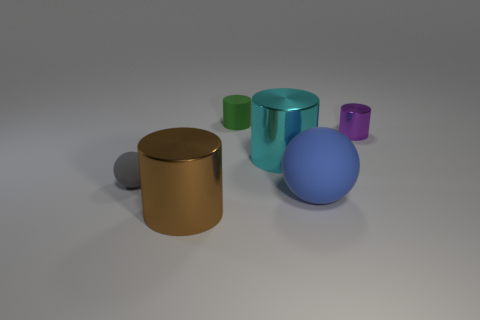Subtract all purple metal cylinders. How many cylinders are left? 3 Subtract all brown cylinders. How many cylinders are left? 3 Add 1 green matte cylinders. How many objects exist? 7 Subtract all blue cylinders. Subtract all cyan blocks. How many cylinders are left? 4 Subtract all spheres. How many objects are left? 4 Subtract all large yellow balls. Subtract all cyan shiny cylinders. How many objects are left? 5 Add 6 rubber objects. How many rubber objects are left? 9 Add 5 cyan metal objects. How many cyan metal objects exist? 6 Subtract 0 green spheres. How many objects are left? 6 